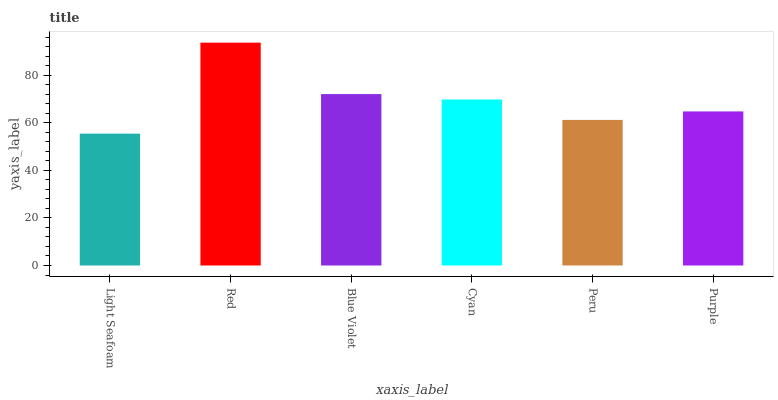Is Light Seafoam the minimum?
Answer yes or no. Yes. Is Red the maximum?
Answer yes or no. Yes. Is Blue Violet the minimum?
Answer yes or no. No. Is Blue Violet the maximum?
Answer yes or no. No. Is Red greater than Blue Violet?
Answer yes or no. Yes. Is Blue Violet less than Red?
Answer yes or no. Yes. Is Blue Violet greater than Red?
Answer yes or no. No. Is Red less than Blue Violet?
Answer yes or no. No. Is Cyan the high median?
Answer yes or no. Yes. Is Purple the low median?
Answer yes or no. Yes. Is Peru the high median?
Answer yes or no. No. Is Blue Violet the low median?
Answer yes or no. No. 